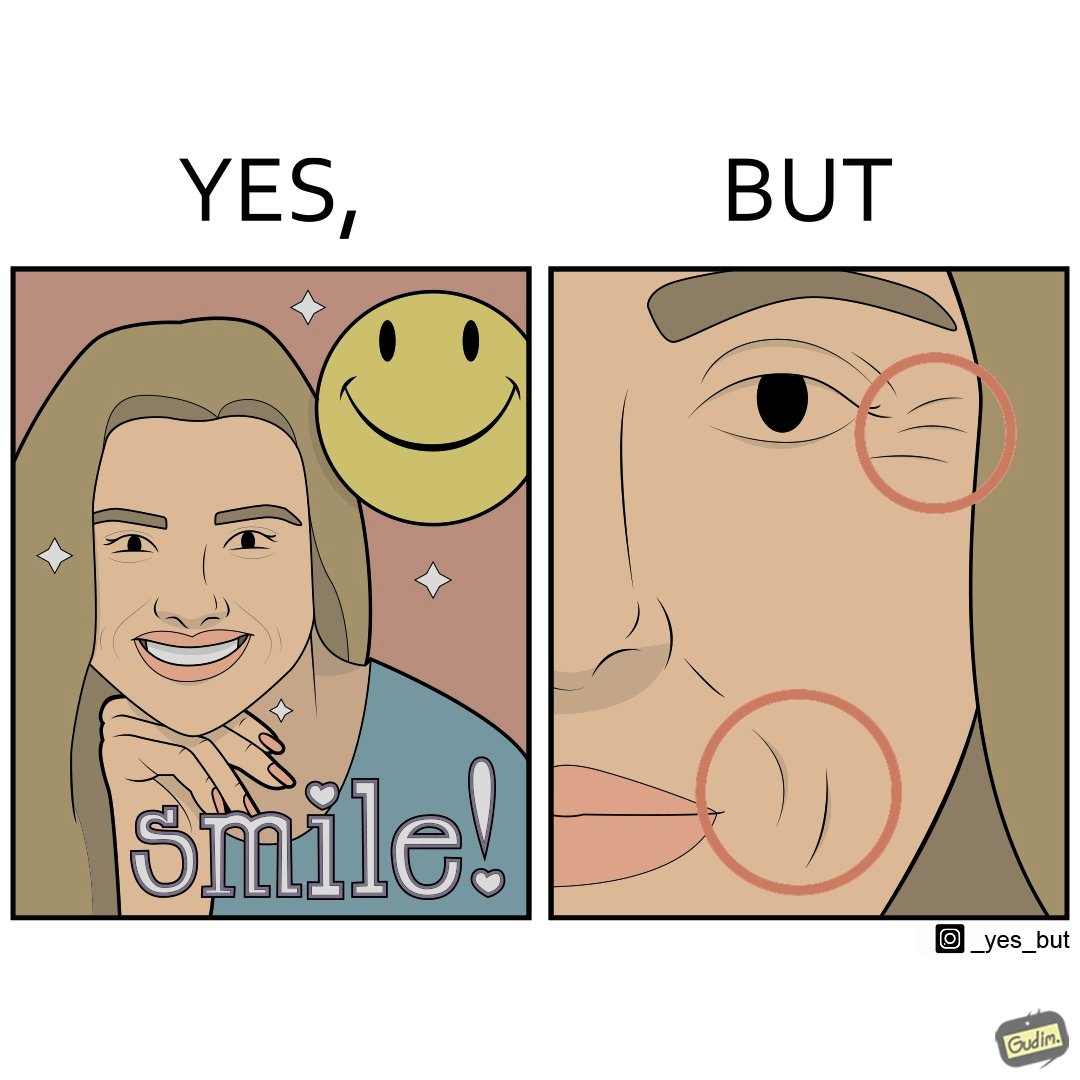Describe what you see in the left and right parts of this image. In the left part of the image: The image shows a woman smiling with a text saying the word "smile!".  There is also a yellow smiley face in the image. In the right part of the image: The image shows a closeup of the face of a woman. The image has red circles around the wrinkles near the woman's lips and eyes highlighting them. 